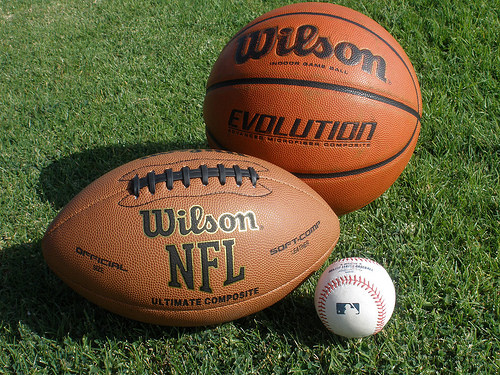<image>
Can you confirm if the baseball is behind the football? No. The baseball is not behind the football. From this viewpoint, the baseball appears to be positioned elsewhere in the scene. Is the baseball on the football? No. The baseball is not positioned on the football. They may be near each other, but the baseball is not supported by or resting on top of the football. Is there a fooball in front of the baseball? No. The fooball is not in front of the baseball. The spatial positioning shows a different relationship between these objects. 